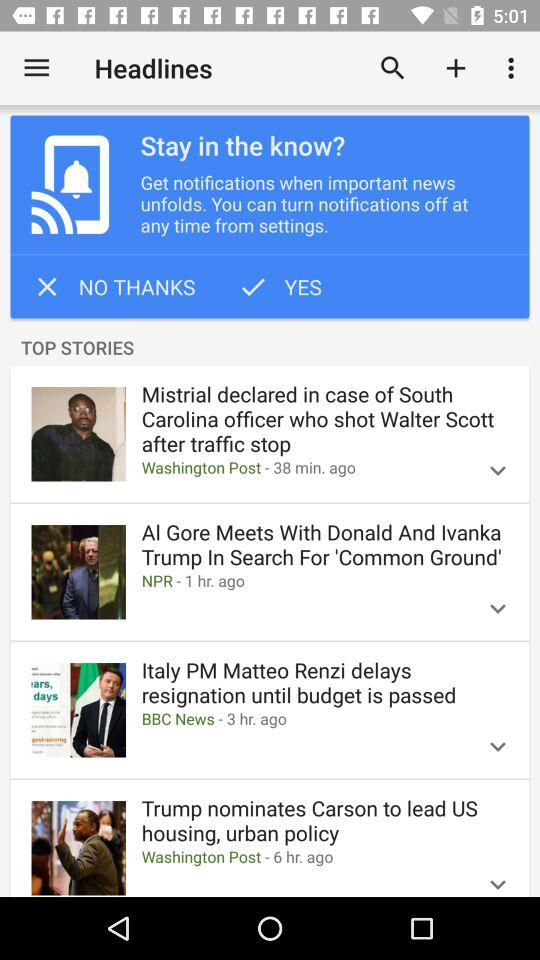How many stories are in the top stories section?
Answer the question using a single word or phrase. 4 